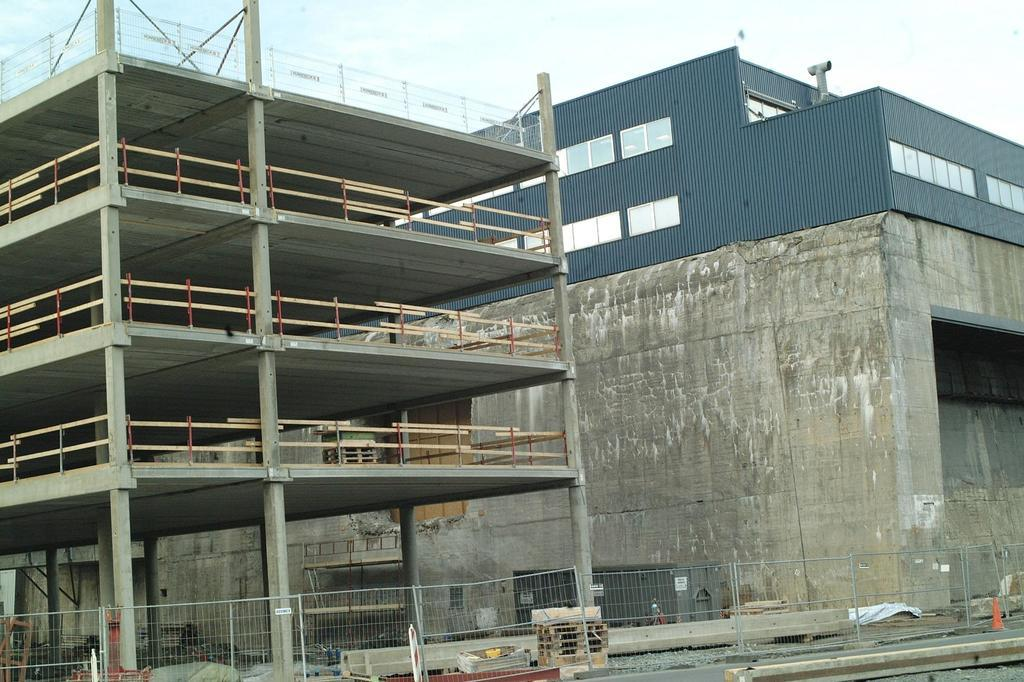What structures are located in the middle of the image? There are buildings in the middle of the image. What is at the bottom of the image? There is a fence at the bottom of the image. What is visible at the top of the image? The sky is visible at the top of the image. How many arms are visible in the image? There are no arms visible in the image. What type of calendar is hanging on the fence in the image? There is no calendar present in the image. 